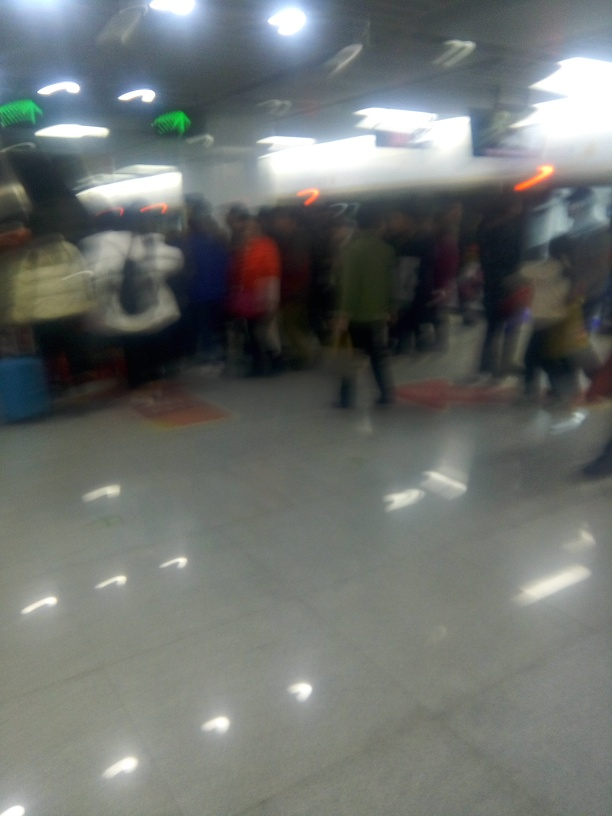Can you describe the setting depicted in this blurred image? While the blurring limits the detail, the image seems to show a busy indoor environment, possibly a subway station or a public area with artificial lighting overhead and people gathered in groups, which could indicate a waiting area or queuing line. 